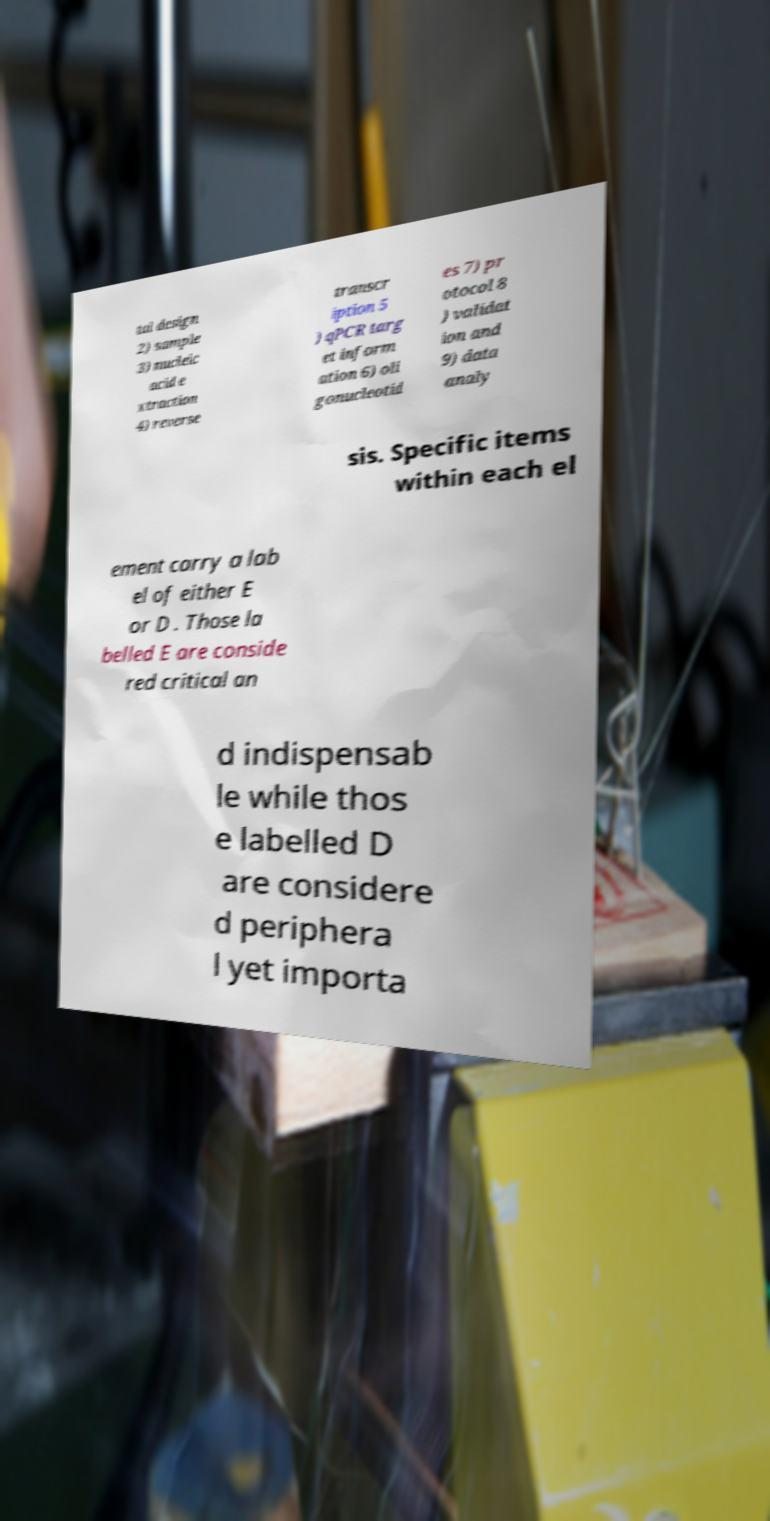Can you accurately transcribe the text from the provided image for me? tal design 2) sample 3) nucleic acid e xtraction 4) reverse transcr iption 5 ) qPCR targ et inform ation 6) oli gonucleotid es 7) pr otocol 8 ) validat ion and 9) data analy sis. Specific items within each el ement carry a lab el of either E or D . Those la belled E are conside red critical an d indispensab le while thos e labelled D are considere d periphera l yet importa 